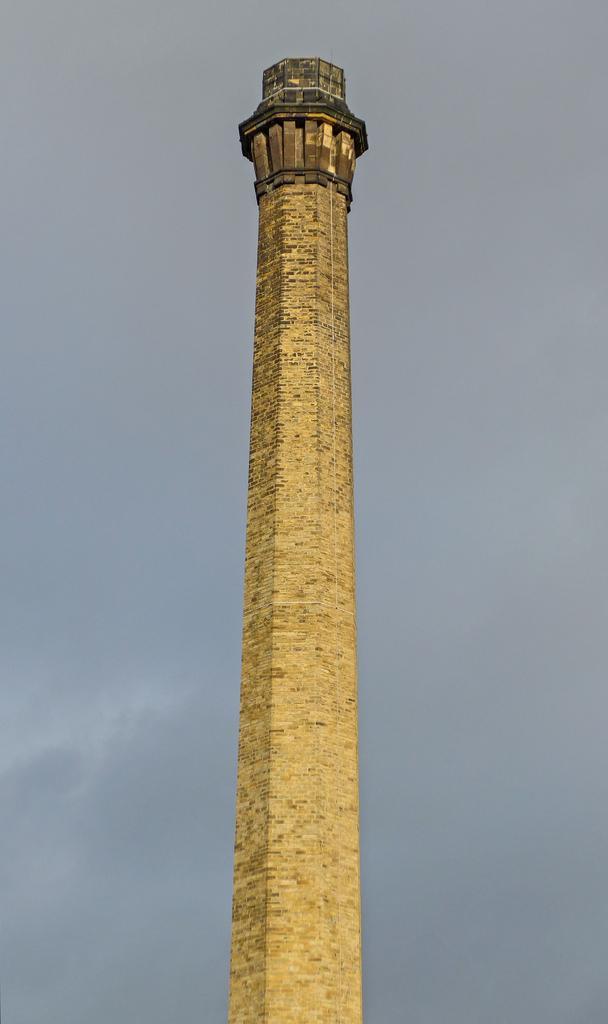Can you describe this image briefly? Here in this picture we can see a tower present on the ground over there and we can also see clouds in the sky. 